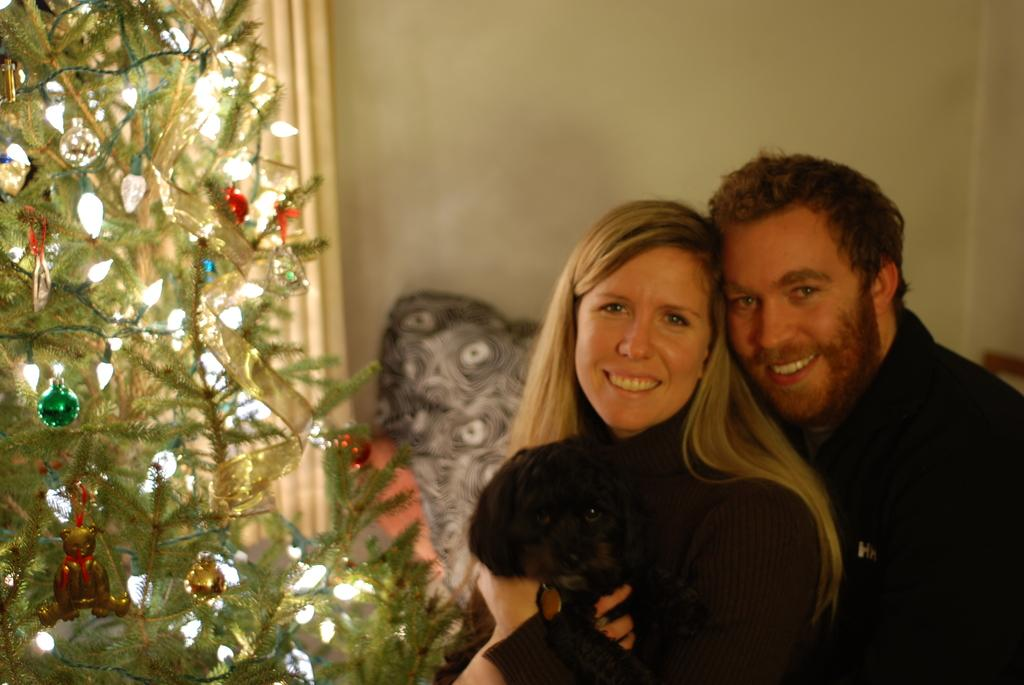How many people are in the image? There are two people in the image: a man and a woman. What is the woman holding in the image? The woman is holding a dog. Can you describe the decorative items on the tree in the image? Unfortunately, the facts provided do not give any details about the decorative items on the tree. What is visible in the background of the image? There is a wall in the background of the image. What type of butter is being used to decorate the faucet in the image? There is no butter or faucet present in the image. 